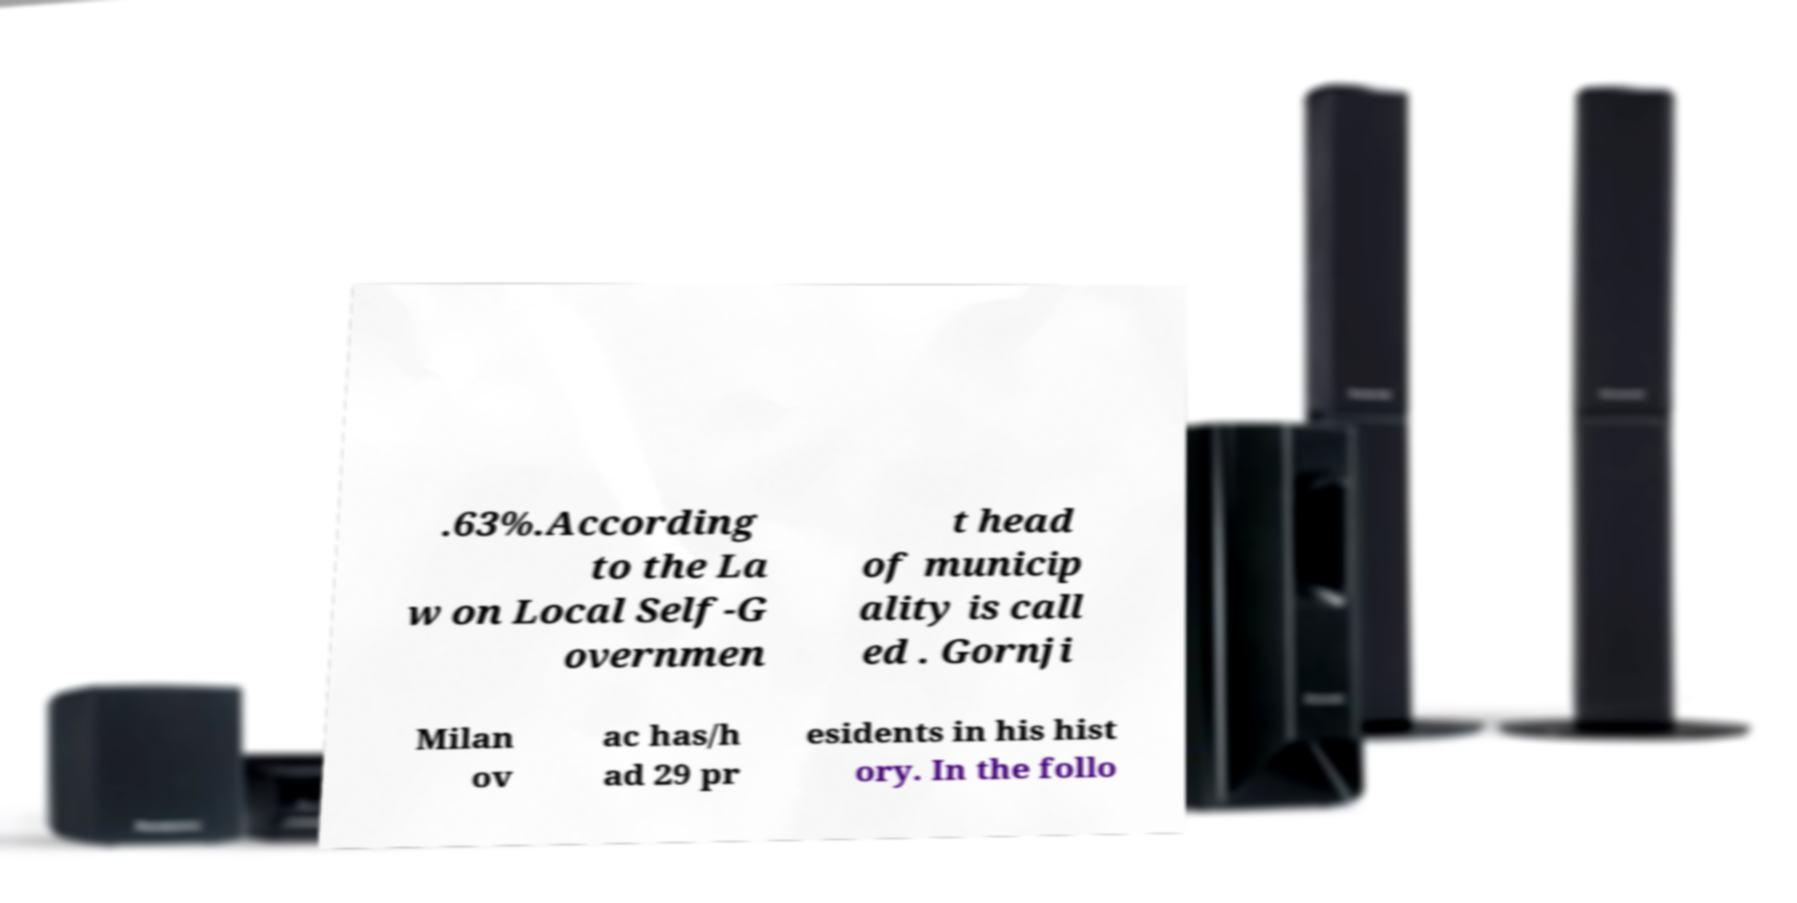Can you accurately transcribe the text from the provided image for me? .63%.According to the La w on Local Self-G overnmen t head of municip ality is call ed . Gornji Milan ov ac has/h ad 29 pr esidents in his hist ory. In the follo 